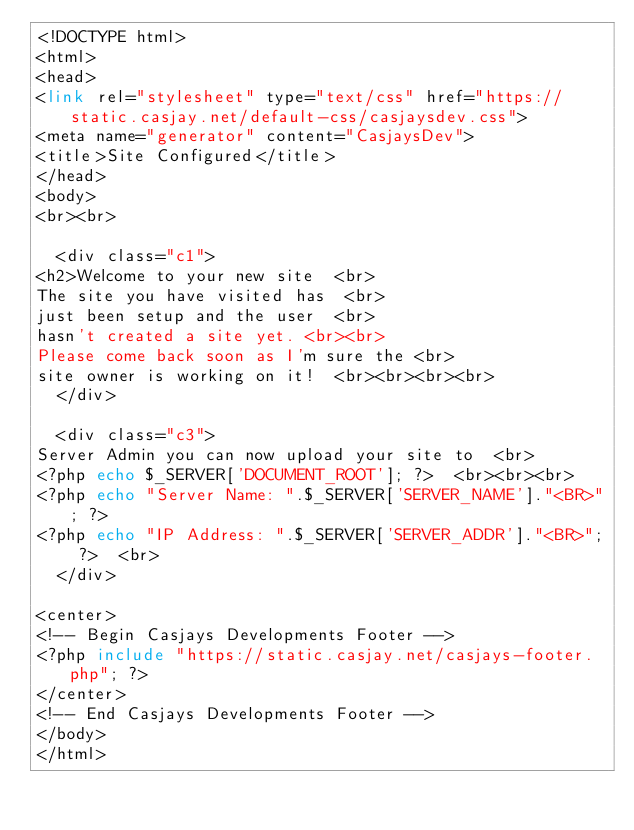Convert code to text. <code><loc_0><loc_0><loc_500><loc_500><_PHP_><!DOCTYPE html>
<html>
<head>
<link rel="stylesheet" type="text/css" href="https://static.casjay.net/default-css/casjaysdev.css">
<meta name="generator" content="CasjaysDev">
<title>Site Configured</title>
</head>
<body>
<br><br>

  <div class="c1">
<h2>Welcome to your new site  <br>
The site you have visited has  <br>
just been setup and the user  <br>
hasn't created a site yet. <br><br>
Please come back soon as I'm sure the <br>
site owner is working on it!  <br><br><br><br>
  </div>

  <div class="c3">
Server Admin you can now upload your site to  <br>
<?php echo $_SERVER['DOCUMENT_ROOT']; ?>  <br><br><br>
<?php echo "Server Name: ".$_SERVER['SERVER_NAME']."<BR>"; ?>
<?php echo "IP Address: ".$_SERVER['SERVER_ADDR']."<BR>"; ?>  <br>
  </div>

<center>
<!-- Begin Casjays Developments Footer -->
<?php include "https://static.casjay.net/casjays-footer.php"; ?>
</center>
<!-- End Casjays Developments Footer -->
</body>
</html>
</code> 